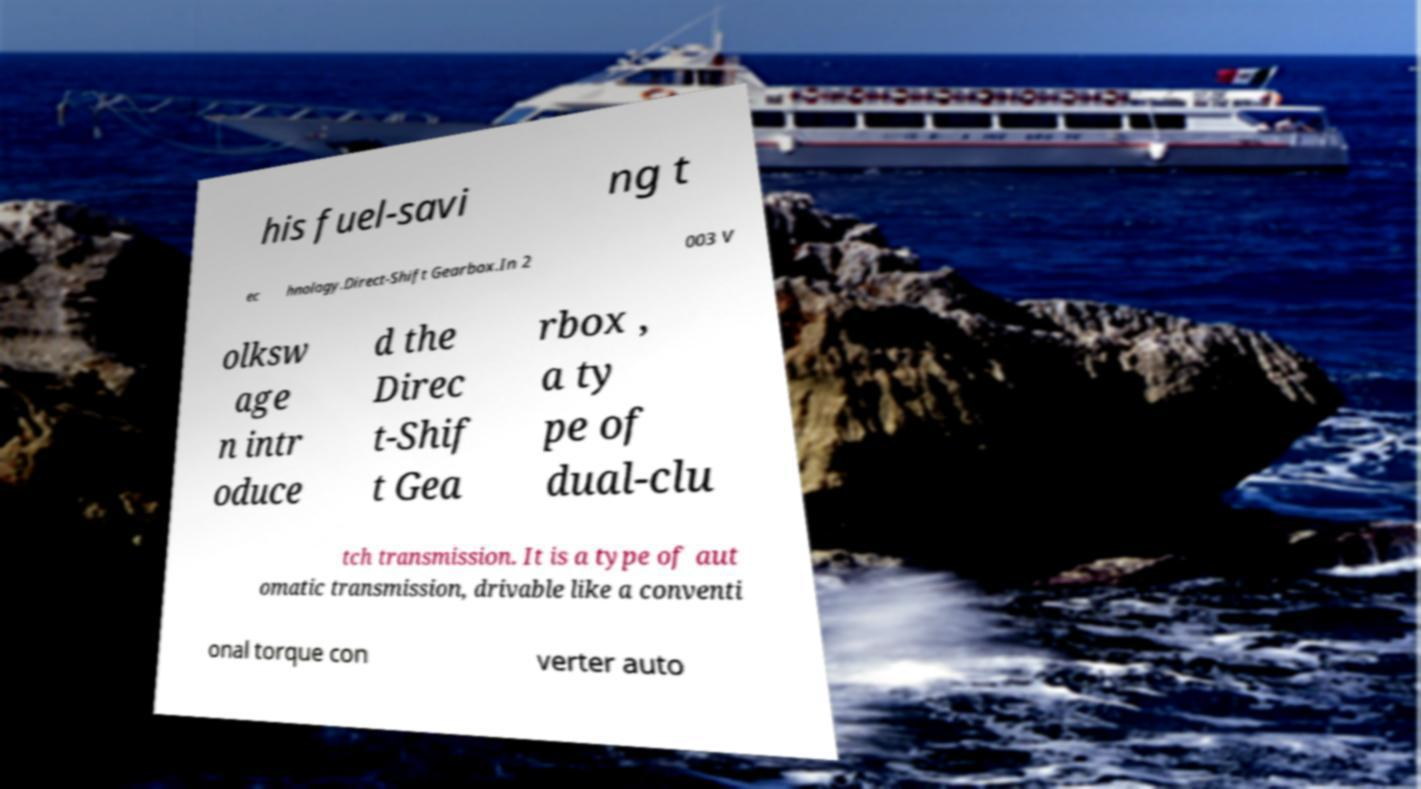Could you extract and type out the text from this image? his fuel-savi ng t ec hnology.Direct-Shift Gearbox.In 2 003 V olksw age n intr oduce d the Direc t-Shif t Gea rbox , a ty pe of dual-clu tch transmission. It is a type of aut omatic transmission, drivable like a conventi onal torque con verter auto 